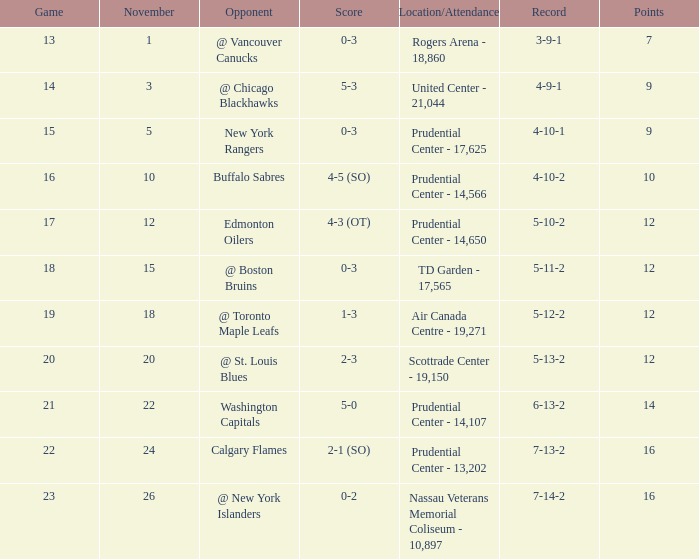What is the upper limit for the number of points? 16.0. 